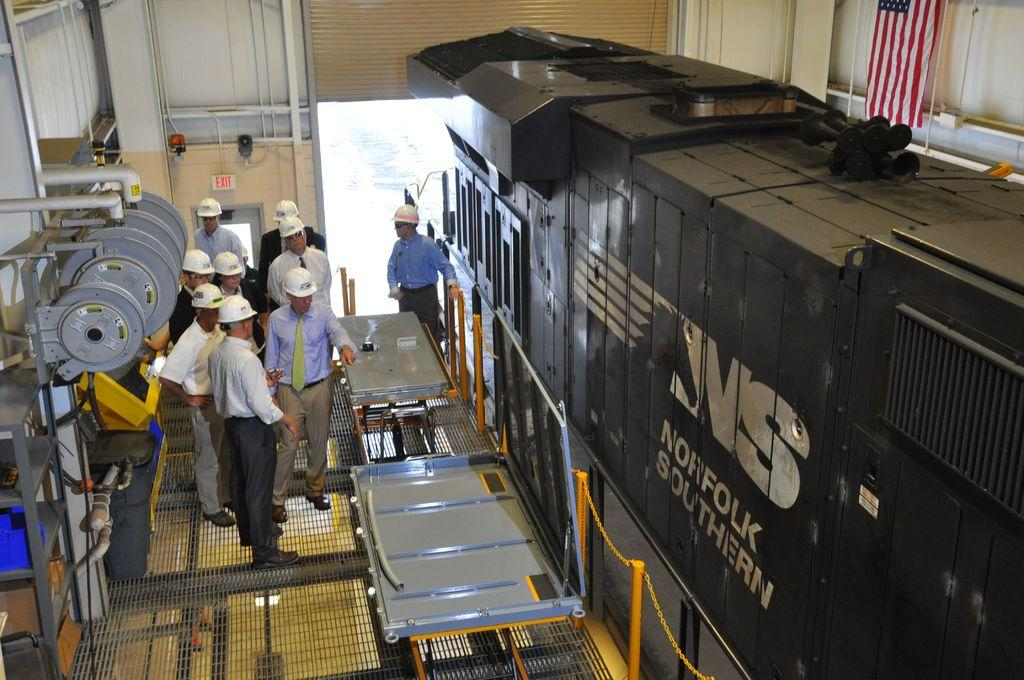What can be seen on the left side of the image? There is a group of people on the left side of the image. What are the people wearing on their heads? The people are wearing helmets. What type of clothing are the people wearing on their lower bodies? The people are wearing trousers. What type of clothing are the people wearing around their necks? The people are wearing ties. What type of clothing are the people wearing on their upper bodies? The people are wearing shirts. What can be seen on the right side of the image? There is a rail engine on the right side of the image. What is the color of the rail engine? The rail engine is grey in color. Is the group of people standing in quicksand in the image? No, there is no quicksand present in the image. 